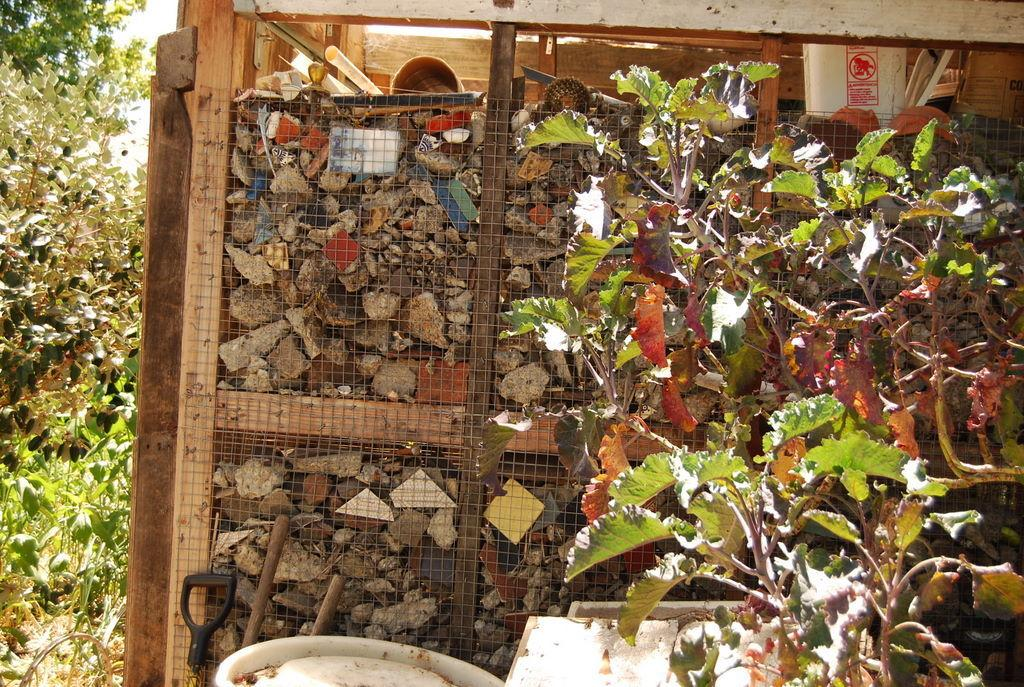What is inside the box that is visible in the image? There is a box with stones and paper in the image. What type of natural elements can be seen in the image? There are trees in the image. Can you describe the main object in the image? The box is present in the image. Is there an umbrella being used by any of the trees in the image? There is no umbrella present in the image, and trees do not use umbrellas. Can you tell me how many animals are visible in the image? There is no mention of animals or a zoo in the image, so it is not possible to answer that question. 